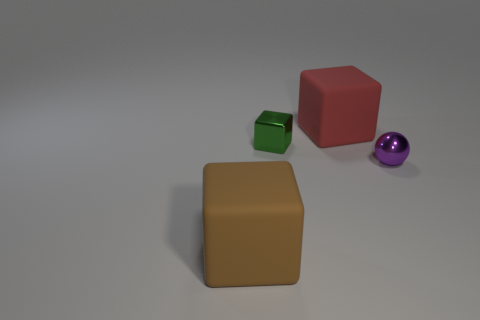Subtract all matte blocks. How many blocks are left? 1 Subtract all red cubes. How many cubes are left? 2 Subtract 2 cubes. How many cubes are left? 1 Subtract 0 cyan spheres. How many objects are left? 4 Subtract all blocks. How many objects are left? 1 Subtract all blue cubes. Subtract all cyan balls. How many cubes are left? 3 Subtract all purple balls. How many cyan blocks are left? 0 Subtract all purple rubber blocks. Subtract all large objects. How many objects are left? 2 Add 3 large brown matte things. How many large brown matte things are left? 4 Add 4 tiny metal objects. How many tiny metal objects exist? 6 